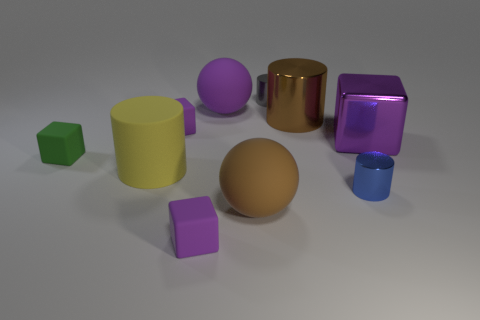Is there a rubber block of the same color as the large metal cube?
Offer a very short reply. Yes. There is a small object that is in front of the brown matte ball; is its color the same as the large ball behind the yellow matte cylinder?
Provide a succinct answer. Yes. What is the size of the sphere that is the same color as the big metallic cylinder?
Make the answer very short. Large. What material is the large cylinder on the left side of the small shiny cylinder that is behind the purple ball made of?
Keep it short and to the point. Rubber. How many balls are either green rubber things or matte objects?
Your answer should be compact. 2. Is the material of the yellow cylinder the same as the green block?
Your answer should be compact. Yes. How many other objects are the same color as the metallic cube?
Provide a short and direct response. 3. The tiny purple object that is behind the brown rubber sphere has what shape?
Make the answer very short. Cube. How many things are either metallic things or big rubber cylinders?
Your response must be concise. 5. Do the blue object and the rubber sphere in front of the green matte object have the same size?
Give a very brief answer. No. 